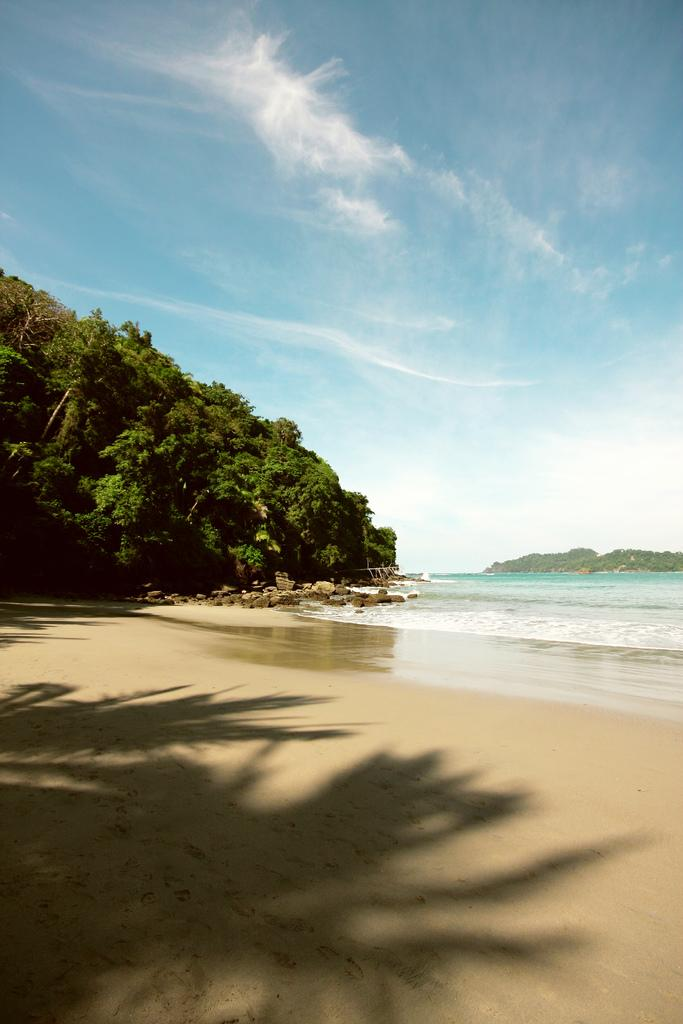What type of natural elements can be seen in the image? There are trees and rocks visible in the image. What else can be seen in the image besides trees and rocks? There is water visible in the image. How would you describe the color of the sky in the image? The sky is blue and white in color. What type of stew is being cooked in the image? There is no stew present in the image; it features trees, rocks, water, and a blue and white sky. Can you see any hair in the image? There is no hair visible in the image. 